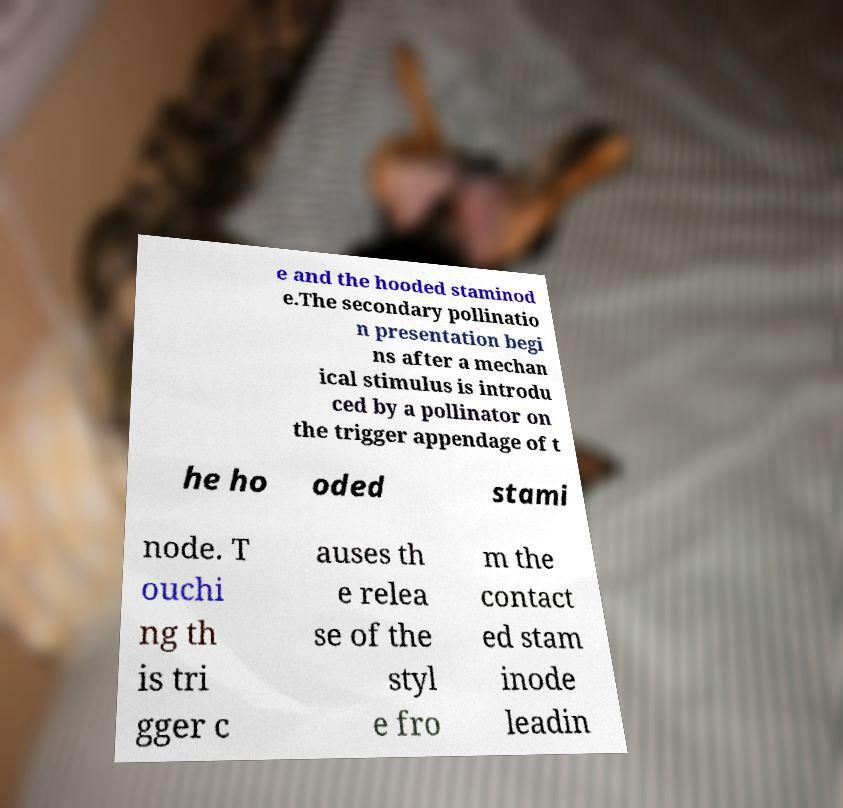Could you assist in decoding the text presented in this image and type it out clearly? e and the hooded staminod e.The secondary pollinatio n presentation begi ns after a mechan ical stimulus is introdu ced by a pollinator on the trigger appendage of t he ho oded stami node. T ouchi ng th is tri gger c auses th e relea se of the styl e fro m the contact ed stam inode leadin 